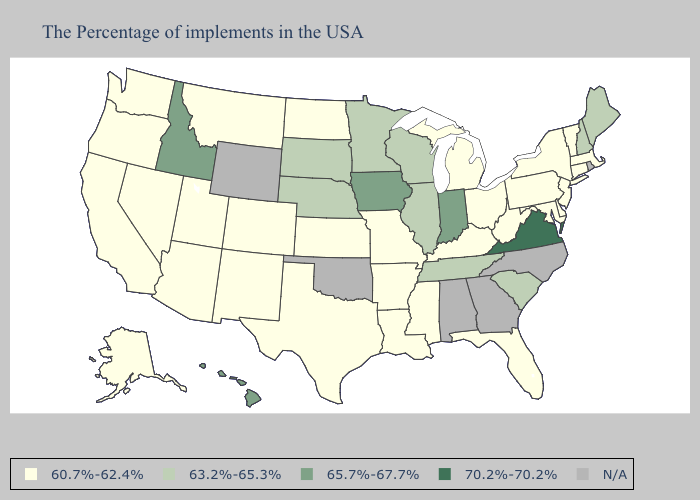What is the value of Iowa?
Short answer required. 65.7%-67.7%. Does Texas have the highest value in the USA?
Quick response, please. No. Among the states that border New Jersey , which have the lowest value?
Concise answer only. New York, Delaware, Pennsylvania. Name the states that have a value in the range 63.2%-65.3%?
Concise answer only. Maine, New Hampshire, South Carolina, Tennessee, Wisconsin, Illinois, Minnesota, Nebraska, South Dakota. What is the value of Washington?
Answer briefly. 60.7%-62.4%. Name the states that have a value in the range 63.2%-65.3%?
Give a very brief answer. Maine, New Hampshire, South Carolina, Tennessee, Wisconsin, Illinois, Minnesota, Nebraska, South Dakota. Name the states that have a value in the range 65.7%-67.7%?
Answer briefly. Indiana, Iowa, Idaho, Hawaii. Name the states that have a value in the range N/A?
Be succinct. Rhode Island, North Carolina, Georgia, Alabama, Oklahoma, Wyoming. What is the lowest value in states that border Mississippi?
Give a very brief answer. 60.7%-62.4%. What is the highest value in the Northeast ?
Be succinct. 63.2%-65.3%. Name the states that have a value in the range 70.2%-70.2%?
Be succinct. Virginia. What is the lowest value in the USA?
Give a very brief answer. 60.7%-62.4%. Name the states that have a value in the range 70.2%-70.2%?
Be succinct. Virginia. Name the states that have a value in the range 63.2%-65.3%?
Short answer required. Maine, New Hampshire, South Carolina, Tennessee, Wisconsin, Illinois, Minnesota, Nebraska, South Dakota. What is the highest value in the South ?
Be succinct. 70.2%-70.2%. 